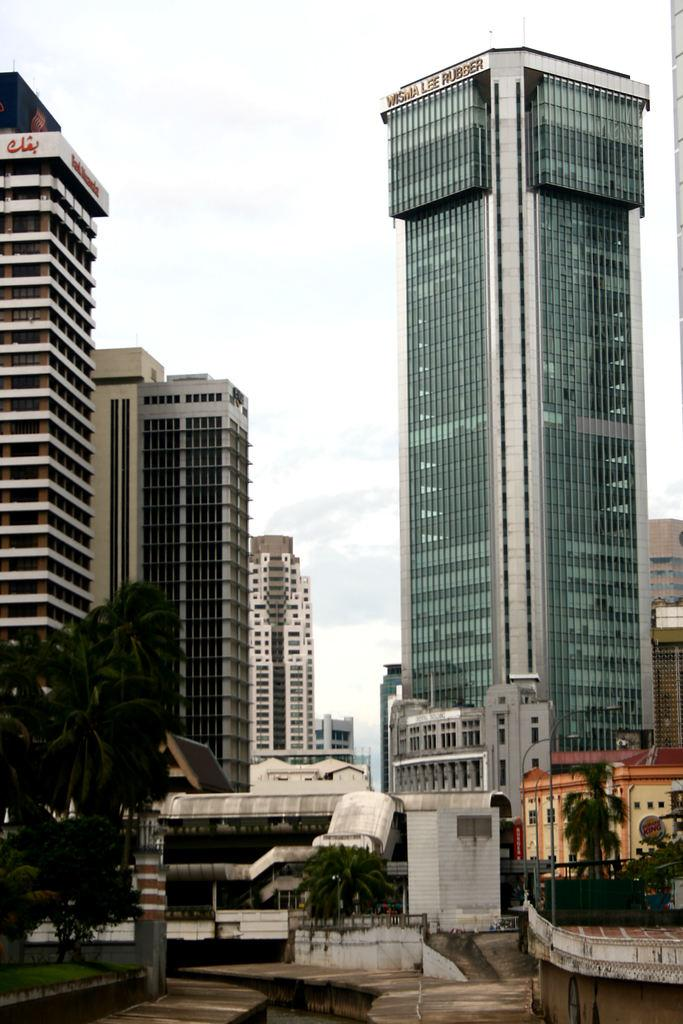What type of structures can be seen in the image? There are buildings in the image. What other natural elements are present in the image? There are trees in the image. What can be seen in the distance in the image? The sky is visible in the background of the image. What type of poison is being used by the trees in the image? There is no mention of poison in the image; the trees are not using any poison. 